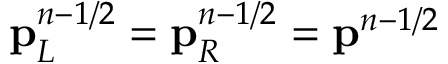Convert formula to latex. <formula><loc_0><loc_0><loc_500><loc_500>p _ { L } ^ { n - 1 / 2 } = p _ { R } ^ { n - 1 / 2 } = p ^ { n - 1 / 2 }</formula> 